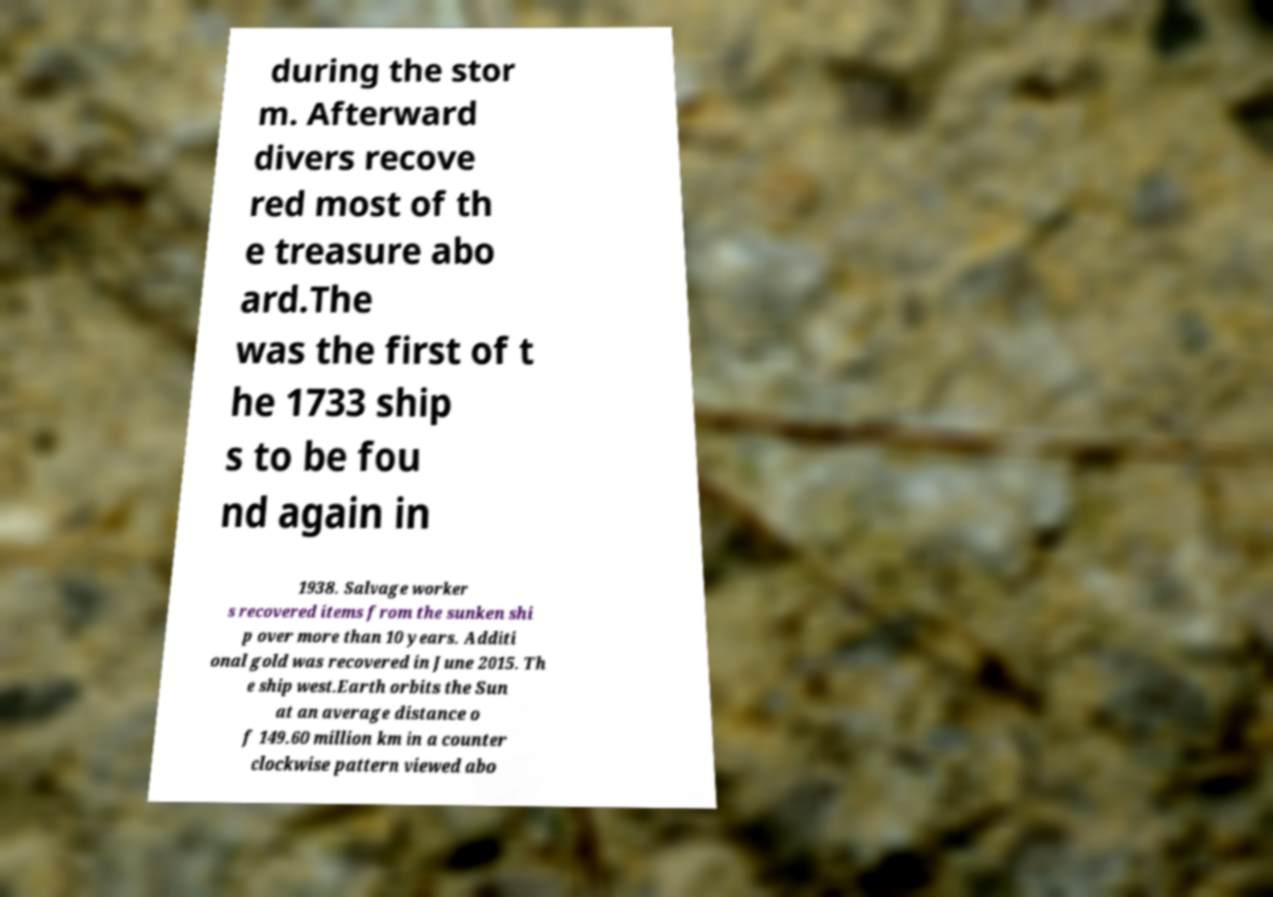Please read and relay the text visible in this image. What does it say? during the stor m. Afterward divers recove red most of th e treasure abo ard.The was the first of t he 1733 ship s to be fou nd again in 1938. Salvage worker s recovered items from the sunken shi p over more than 10 years. Additi onal gold was recovered in June 2015. Th e ship west.Earth orbits the Sun at an average distance o f 149.60 million km in a counter clockwise pattern viewed abo 